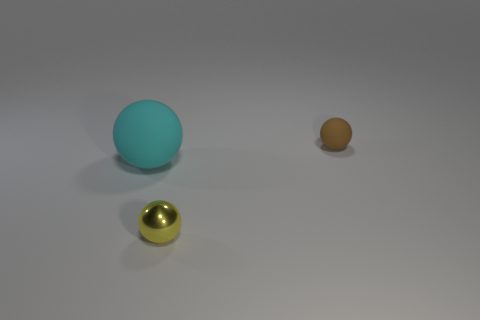Subtract all tiny brown rubber balls. How many balls are left? 2 Add 1 small yellow cylinders. How many objects exist? 4 Subtract all cyan balls. How many balls are left? 2 Subtract all blue spheres. Subtract all blue cubes. How many spheres are left? 3 Subtract all tiny red rubber objects. Subtract all tiny brown things. How many objects are left? 2 Add 2 yellow spheres. How many yellow spheres are left? 3 Add 2 tiny yellow objects. How many tiny yellow objects exist? 3 Subtract 0 red balls. How many objects are left? 3 